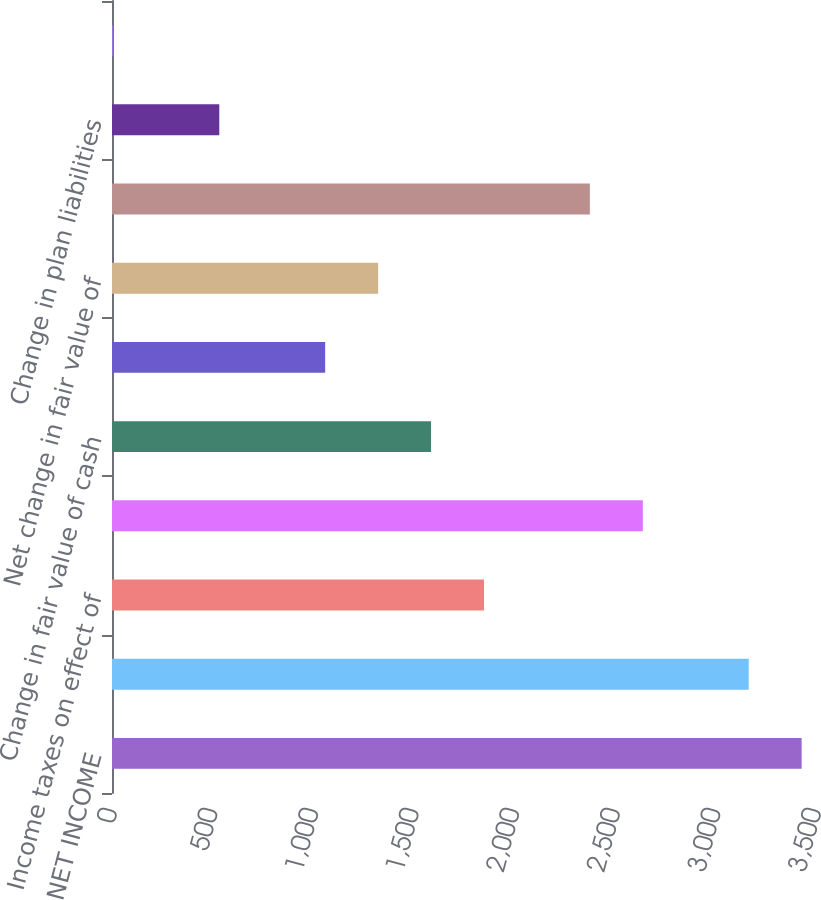Convert chart. <chart><loc_0><loc_0><loc_500><loc_500><bar_chart><fcel>NET INCOME<fcel>Effect of hedge losses<fcel>Income taxes on effect of<fcel>Net effect of hedge losses<fcel>Change in fair value of cash<fcel>Income taxes on change in fair<fcel>Net change in fair value of<fcel>Change in cash flow hedges<fcel>Change in plan liabilities<fcel>Income taxes on change in plan<nl><fcel>3428.6<fcel>3165.4<fcel>1849.4<fcel>2639<fcel>1586.2<fcel>1059.8<fcel>1323<fcel>2375.8<fcel>533.4<fcel>7<nl></chart> 